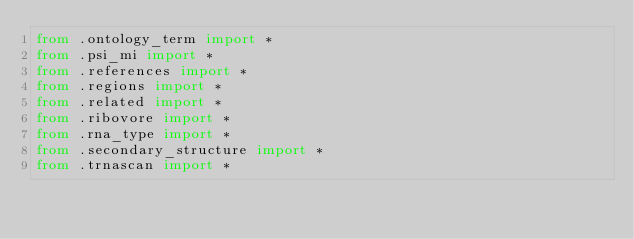<code> <loc_0><loc_0><loc_500><loc_500><_Python_>from .ontology_term import *
from .psi_mi import *
from .references import *
from .regions import *
from .related import *
from .ribovore import *
from .rna_type import *
from .secondary_structure import *
from .trnascan import *
</code> 